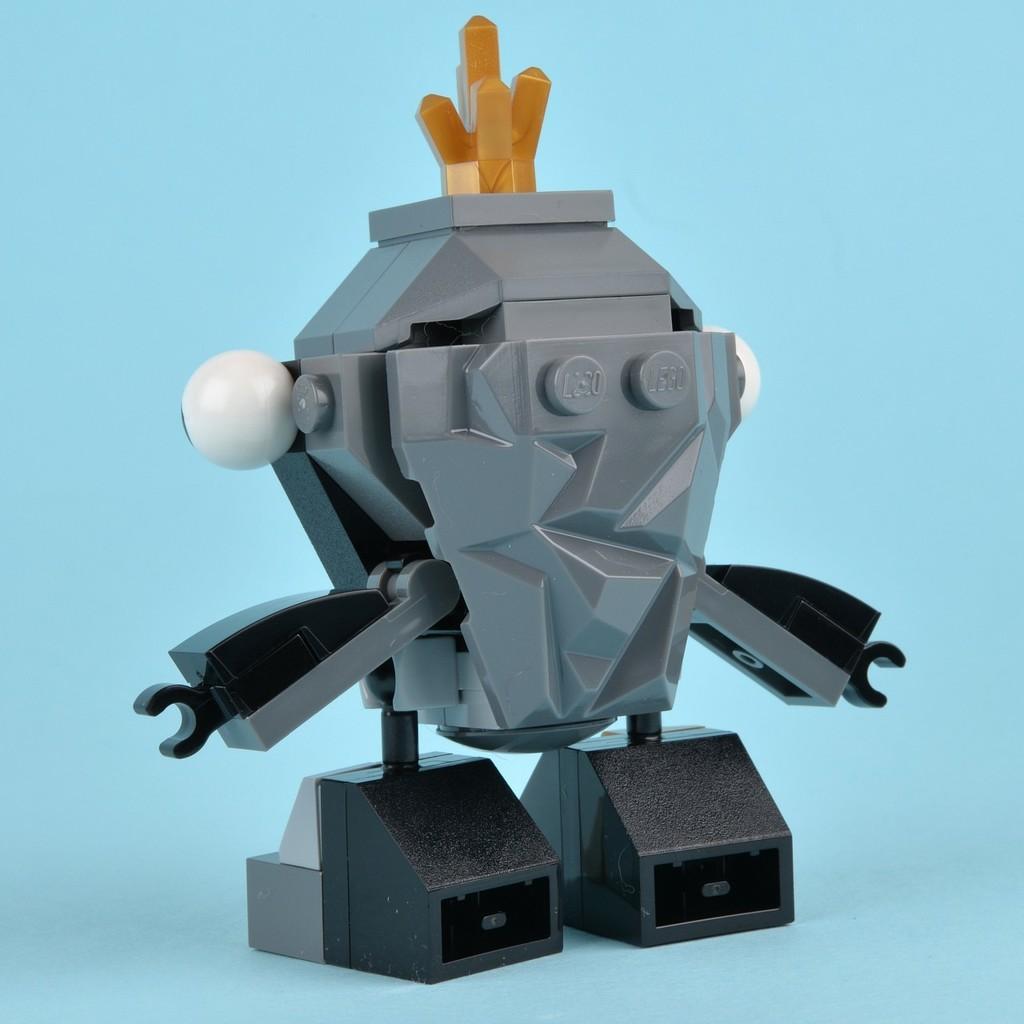How would you summarize this image in a sentence or two? In the middle of the image we can see a toy. 